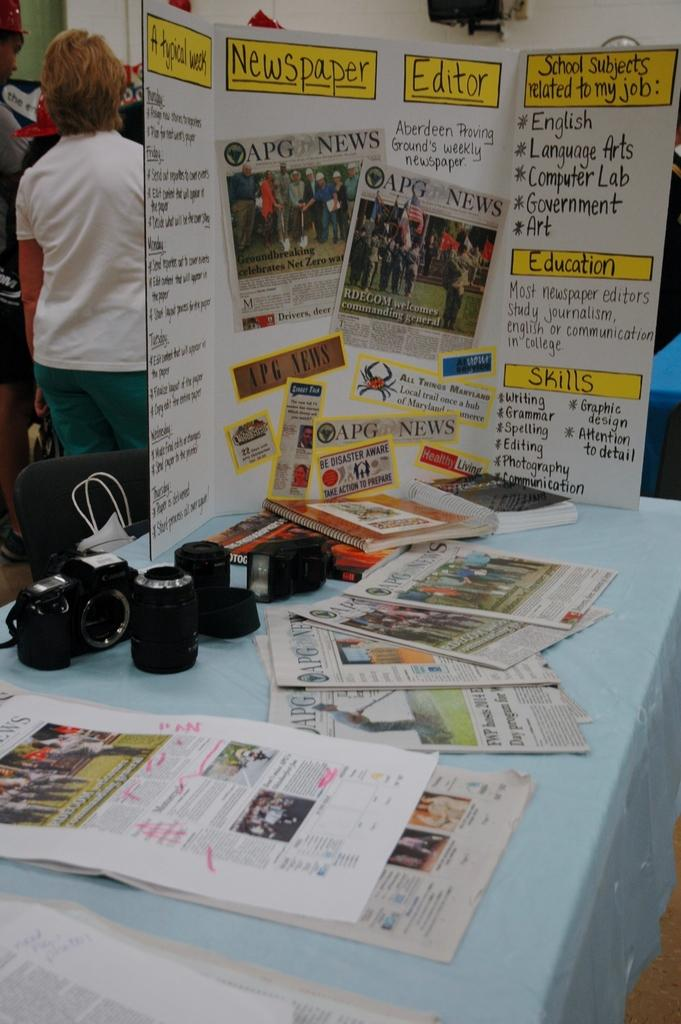Provide a one-sentence caption for the provided image. APG newspaper on a white poster board with education and skills wrote on the front. 